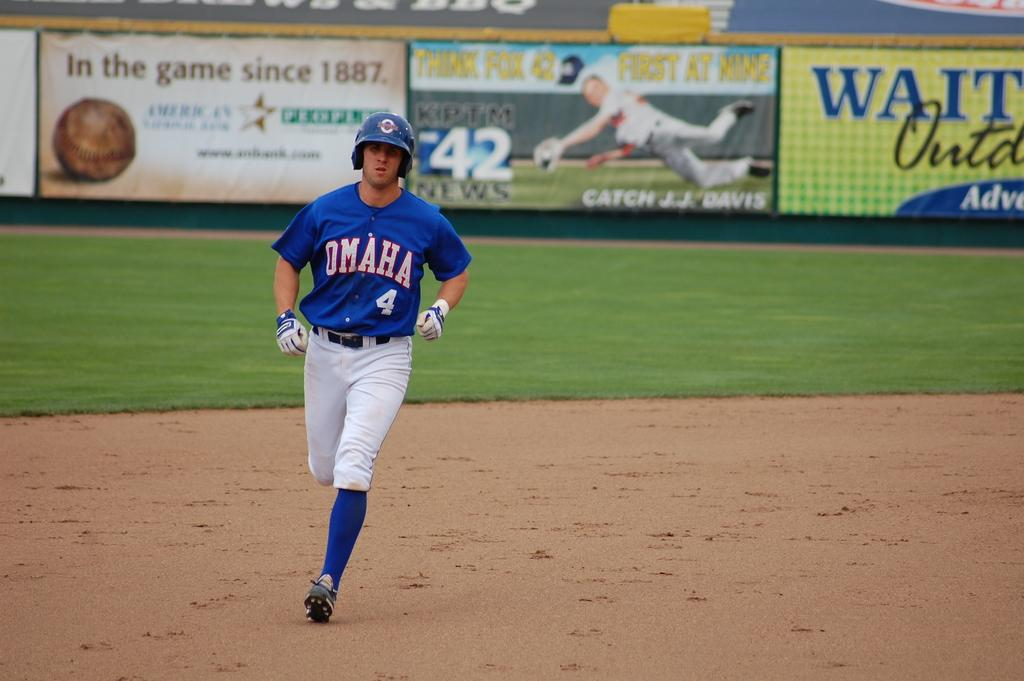Provide a one-sentence caption for the provided image. A baseball player for Omaha is running for a base. 